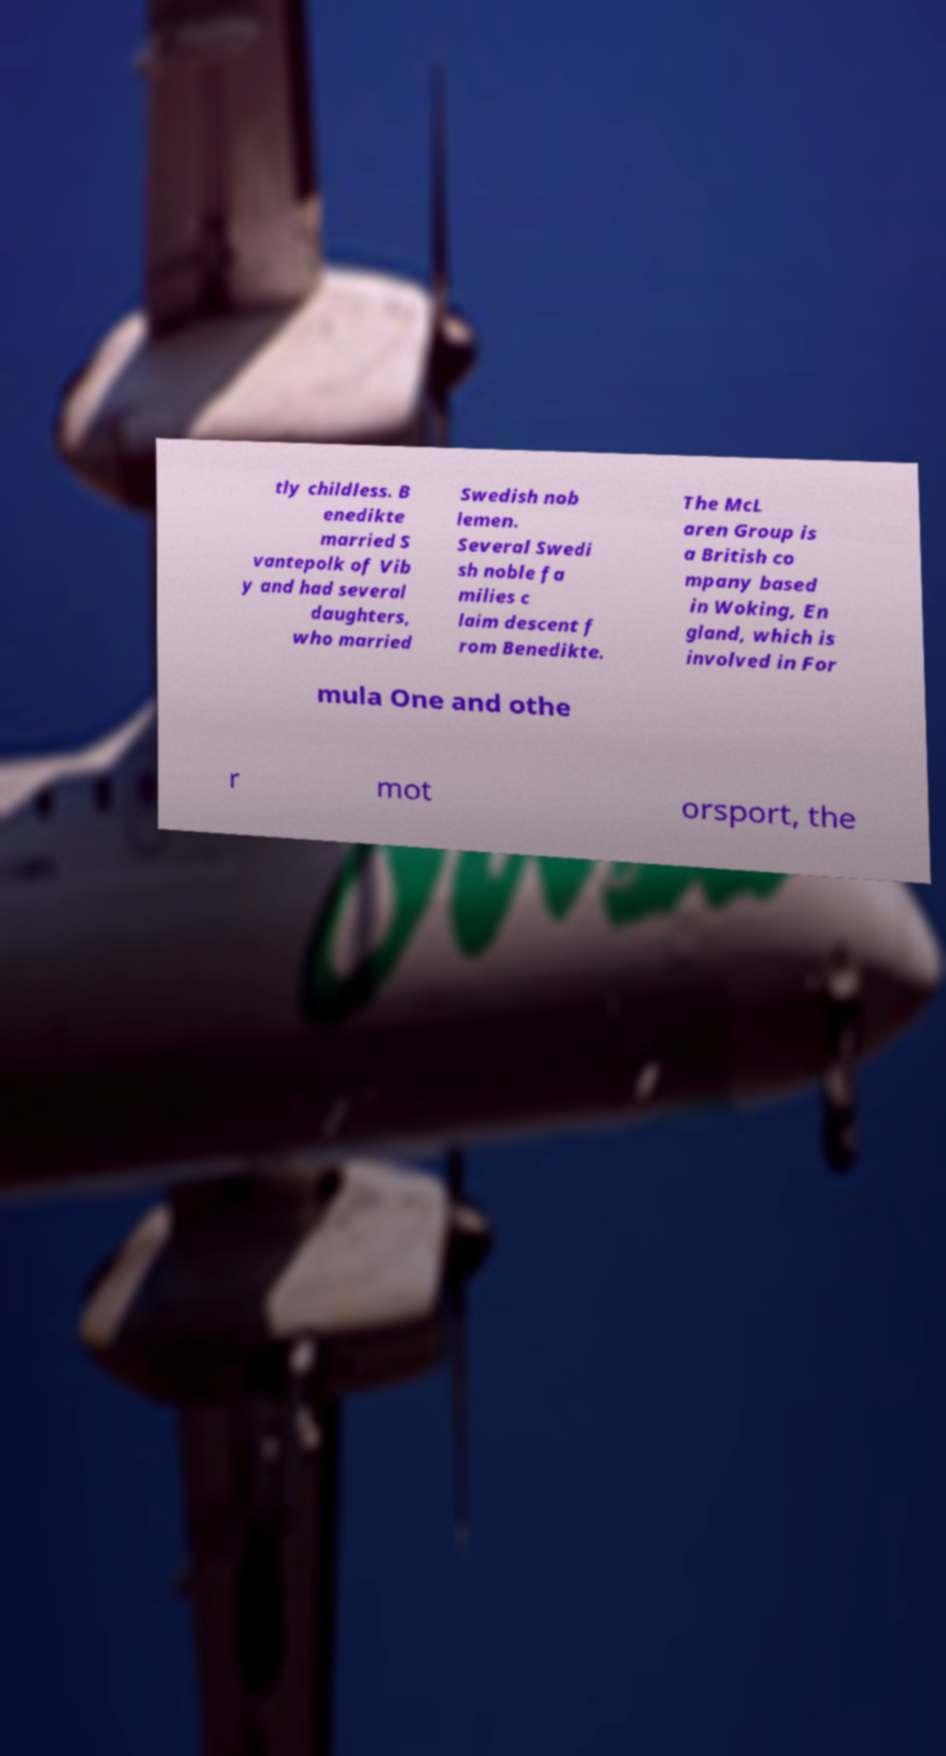Can you accurately transcribe the text from the provided image for me? tly childless. B enedikte married S vantepolk of Vib y and had several daughters, who married Swedish nob lemen. Several Swedi sh noble fa milies c laim descent f rom Benedikte. The McL aren Group is a British co mpany based in Woking, En gland, which is involved in For mula One and othe r mot orsport, the 